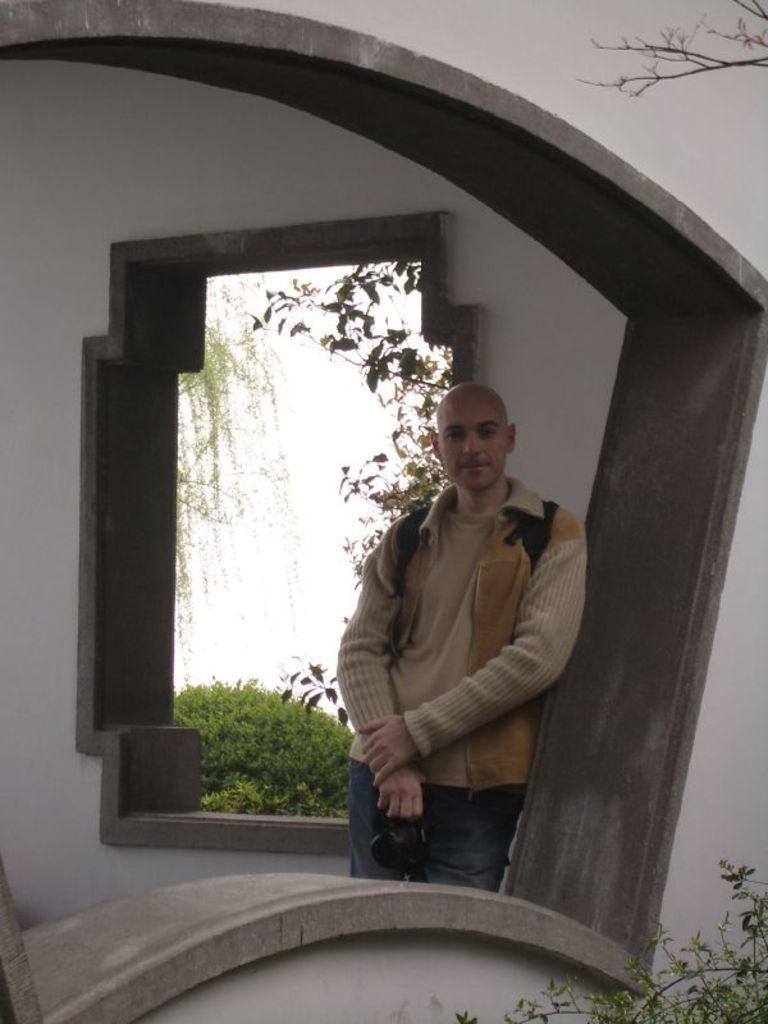In one or two sentences, can you explain what this image depicts? In the picture we can see a wall with a window from it we can see a man standing, he is with a bald head and behind him we can see another wall with a window from it we can see some bushes and plants outside. 